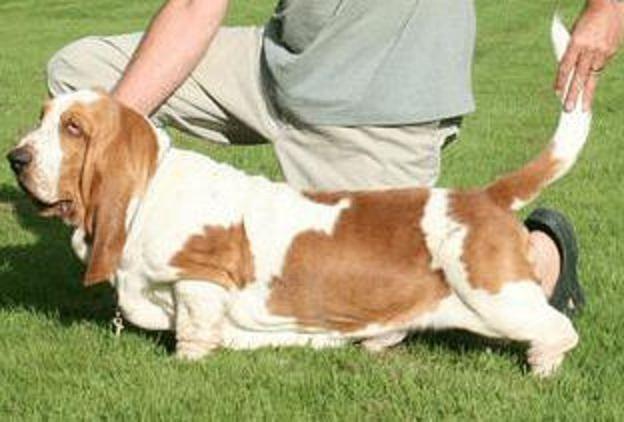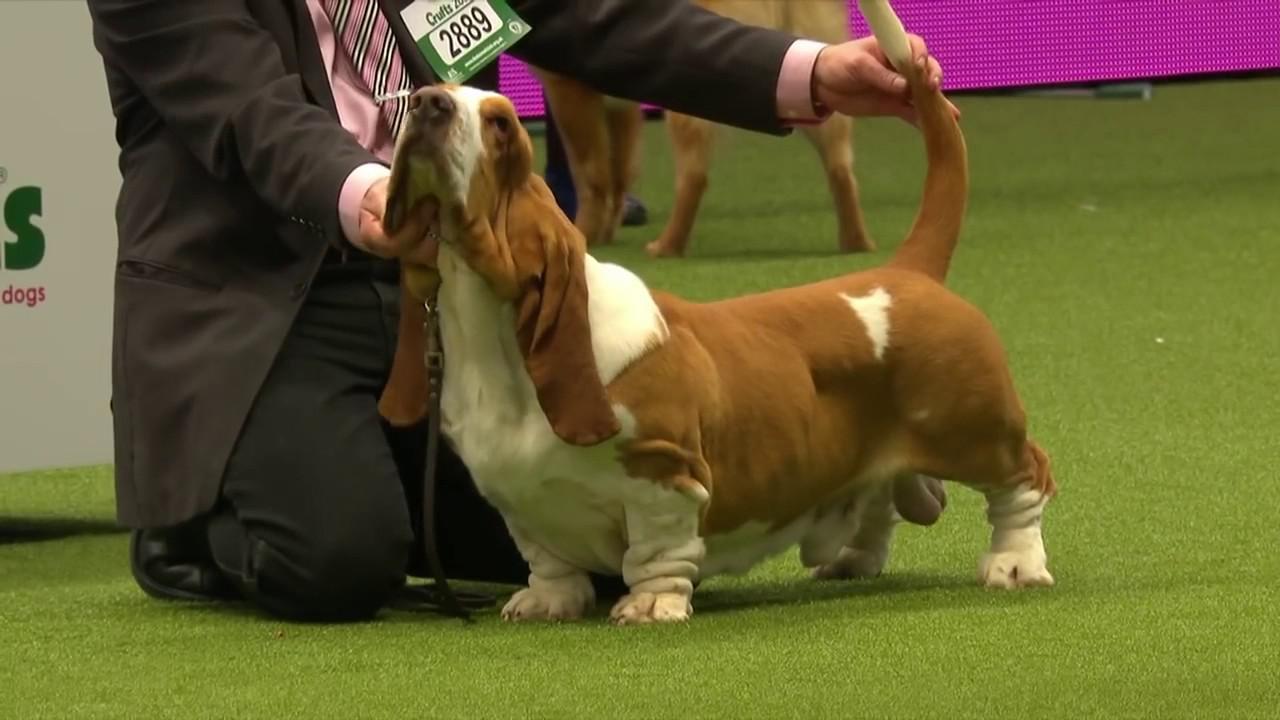The first image is the image on the left, the second image is the image on the right. Evaluate the accuracy of this statement regarding the images: "The dog in the right image is being held on a leash.". Is it true? Answer yes or no. No. 